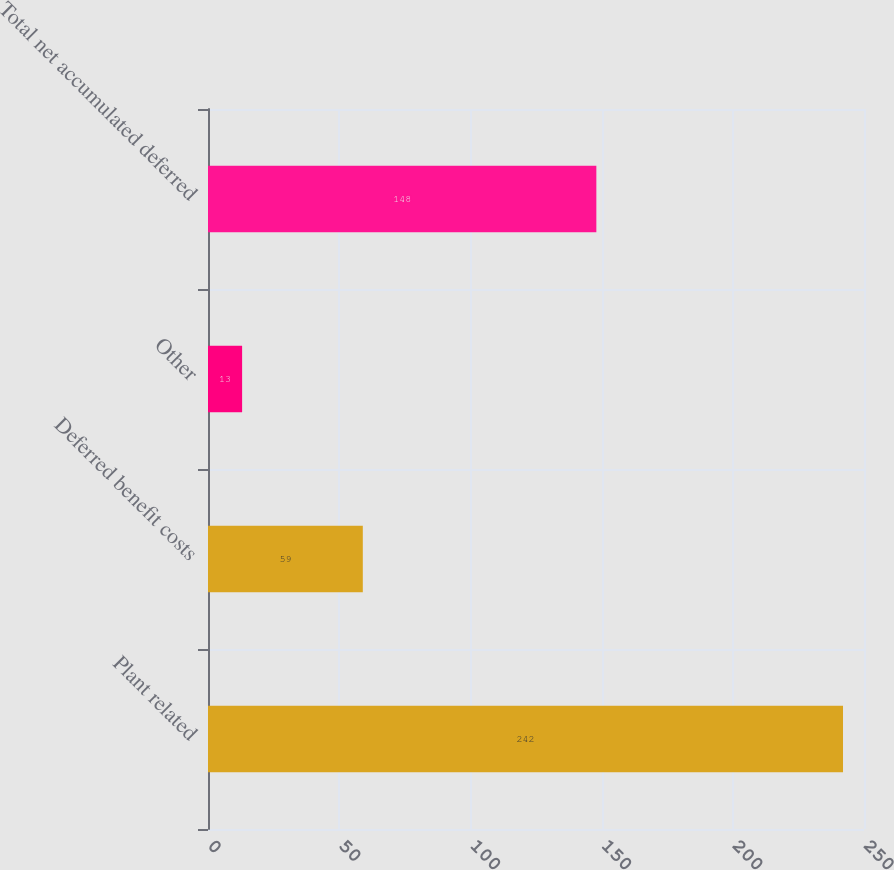Convert chart. <chart><loc_0><loc_0><loc_500><loc_500><bar_chart><fcel>Plant related<fcel>Deferred benefit costs<fcel>Other<fcel>Total net accumulated deferred<nl><fcel>242<fcel>59<fcel>13<fcel>148<nl></chart> 